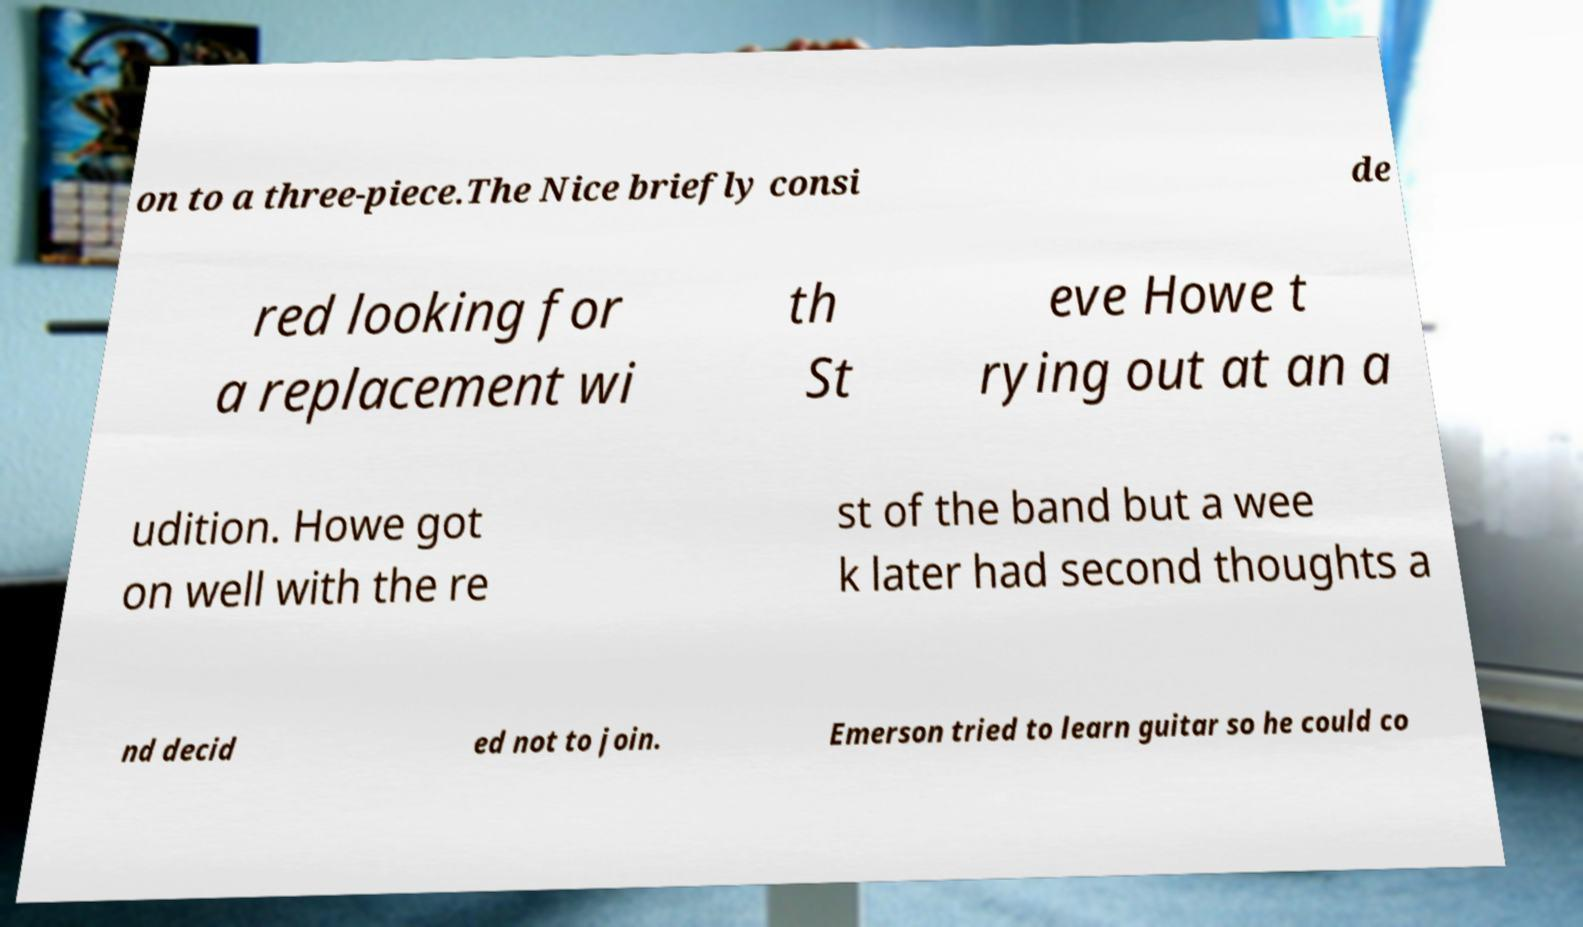Can you read and provide the text displayed in the image?This photo seems to have some interesting text. Can you extract and type it out for me? on to a three-piece.The Nice briefly consi de red looking for a replacement wi th St eve Howe t rying out at an a udition. Howe got on well with the re st of the band but a wee k later had second thoughts a nd decid ed not to join. Emerson tried to learn guitar so he could co 